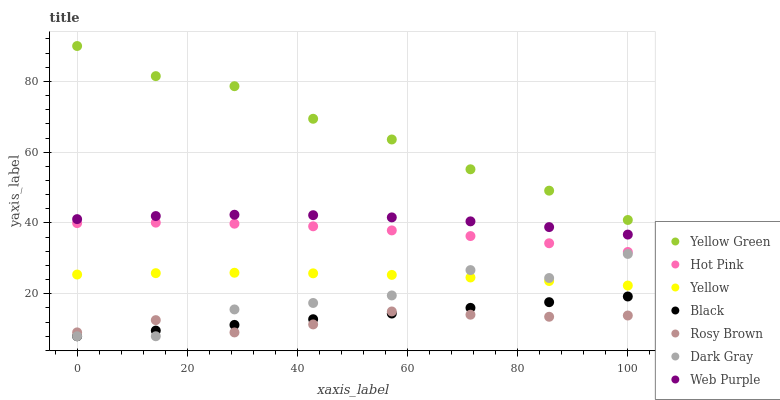Does Rosy Brown have the minimum area under the curve?
Answer yes or no. Yes. Does Yellow Green have the maximum area under the curve?
Answer yes or no. Yes. Does Yellow Green have the minimum area under the curve?
Answer yes or no. No. Does Rosy Brown have the maximum area under the curve?
Answer yes or no. No. Is Black the smoothest?
Answer yes or no. Yes. Is Dark Gray the roughest?
Answer yes or no. Yes. Is Yellow Green the smoothest?
Answer yes or no. No. Is Yellow Green the roughest?
Answer yes or no. No. Does Dark Gray have the lowest value?
Answer yes or no. Yes. Does Rosy Brown have the lowest value?
Answer yes or no. No. Does Yellow Green have the highest value?
Answer yes or no. Yes. Does Rosy Brown have the highest value?
Answer yes or no. No. Is Yellow less than Hot Pink?
Answer yes or no. Yes. Is Web Purple greater than Yellow?
Answer yes or no. Yes. Does Black intersect Dark Gray?
Answer yes or no. Yes. Is Black less than Dark Gray?
Answer yes or no. No. Is Black greater than Dark Gray?
Answer yes or no. No. Does Yellow intersect Hot Pink?
Answer yes or no. No. 